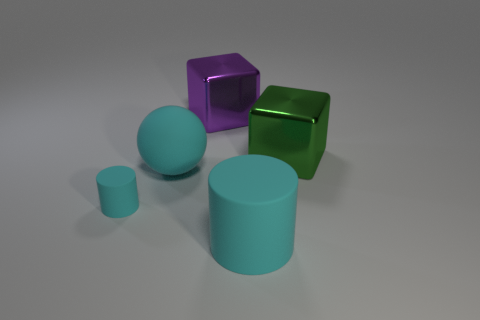Add 4 tiny metal spheres. How many objects exist? 9 Subtract all spheres. How many objects are left? 4 Subtract all green cubes. How many cubes are left? 1 Subtract 1 cylinders. How many cylinders are left? 1 Add 4 balls. How many balls exist? 5 Subtract 0 blue blocks. How many objects are left? 5 Subtract all purple spheres. Subtract all gray blocks. How many spheres are left? 1 Subtract all small cyan cylinders. Subtract all big cyan balls. How many objects are left? 3 Add 3 large purple metal things. How many large purple metal things are left? 4 